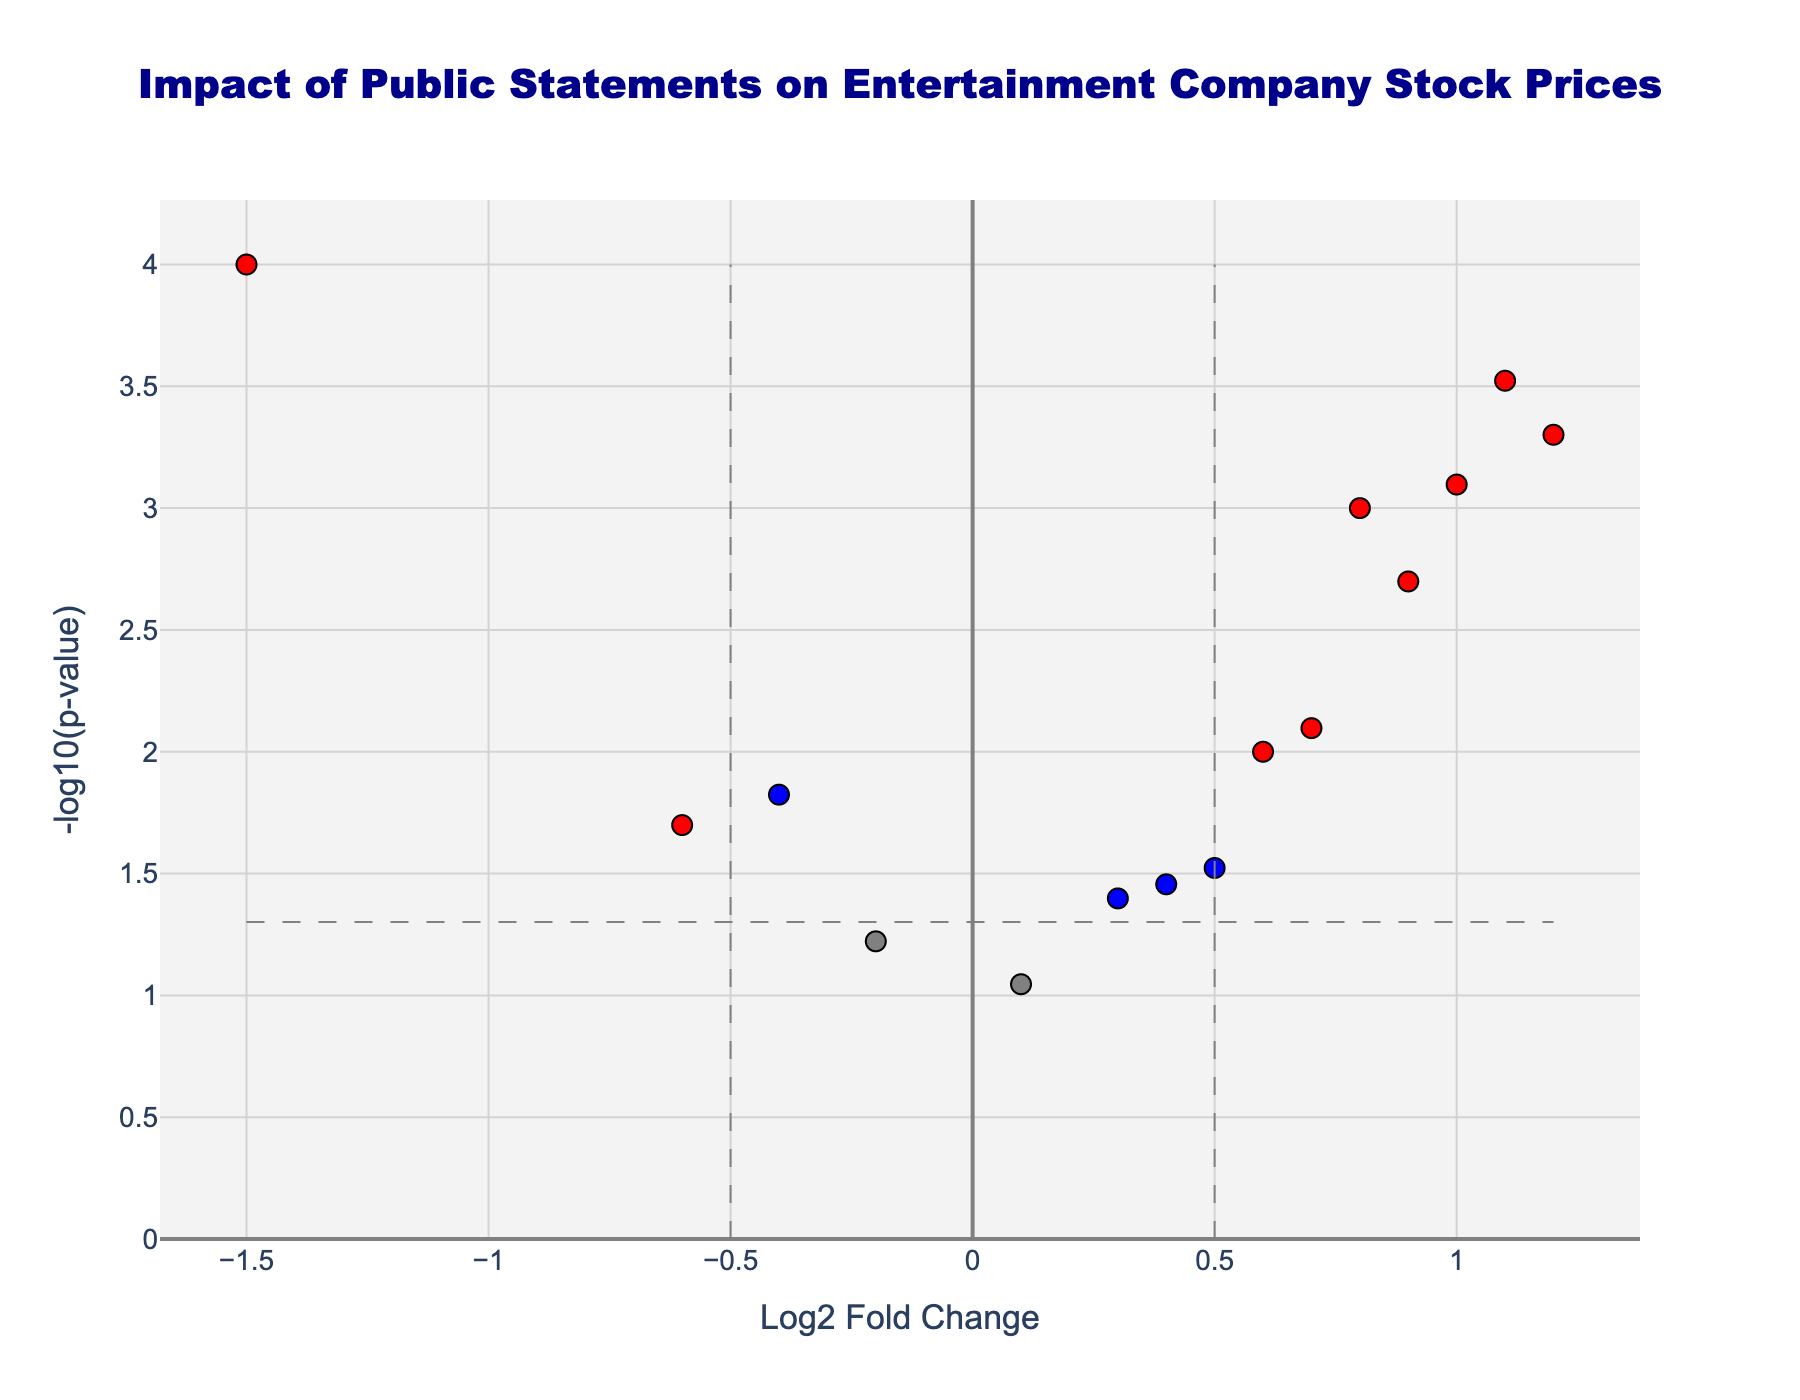How many data points are there in the figure? By observing the figure and counting the individual markers, the total number of data points can be determined.
Answer: 15 Which company’s statement had the highest Log2 Fold Change? We need to look at the x-axis (Log2 Fold Change) and identify the highest value. The data point with the highest value (1.2) corresponds to Netflix’s announcement of subscriber growth.
Answer: Netflix What color represents data points with both significant p-values (less than 0.05) and substantial fold change (absolute value greater than 0.5)? The figure uses color-coding for significance and fold change: Red indicates both significant p-values and substantial fold change.
Answer: Red Which statement had the most negative impact on stock prices? By identifying the data point with the lowest Log2 Fold Change on the x-axis, which represents the most negative impact. The data point (-1.5) corresponds to AMC Theatres bankruptcy rumors.
Answer: AMC Theatres bankruptcy rumors How many statements have a positive Log2 Fold Change and significant p-value (p < 0.05)? We need to count the red and blue data points on the right side of the plot (positive Log2 Fold Change) that also have a significant p-value. There are 7 such points: Disney CEO statement on new streaming strategy, Netflix announcement of subscriber growth, Apple TV+ award-winning series announcement, Lionsgate studio sale speculation, MGM acquisition by Amazon, Netflix content budget increase, and Disney park reopening post-COVID.
Answer: 7 What is the range of -log10(p-value) for the data points shown? To find this, look at the highest and lowest points on the y-axis (-log10(p-value)). The range is from close to 0 to just above 4.
Answer: ~0 to ~4 Which statement had a nearly neutral impact on stock prices (Log2 Fold Change close to 0) but had a relatively significant p-value (p < 0.05)? Look for data points near the zero mark on the x-axis and find one with a significant p-value (p < 0.05). Sony Pictures profit forecast (-0.4) with a p-value of 0.015 falls into this category.
Answer: Sony Pictures profit forecast How does the statement from Warner Bros Discovery compare in impact to the statement from Amazon Prime Video? Compare the x-axis values (Log2 Fold Change) for these two points. Warner Bros Discovery merger update is at -0.6 and Amazon Prime Video content expansion is at 0.5. Warner Bros Discovery has a more negative impact compared to Amazon Prime Video.
Answer: Warner Bros Discovery has a more negative impact What general trend can you observe about the announcements with positive Log2 Fold Change? Observing the right side of the plot (positive Log2 Fold Change), it’s clear that announcements with positive Log2 Fold Change often correspond to impactful and significant p-values, denoted by red and blue colors.
Answer: Positive announcements usually have significant impacts (red or blue) 